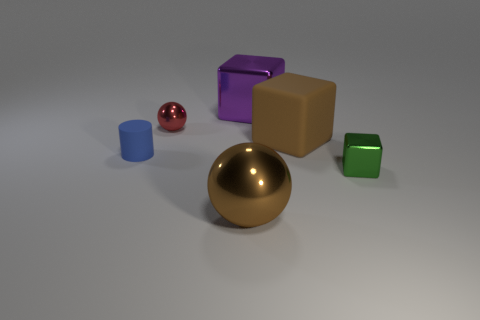Are there any other things that have the same size as the blue matte object?
Your answer should be compact. Yes. How many objects are large shiny objects behind the tiny blue thing or objects that are behind the tiny red thing?
Your answer should be very brief. 1. Do the metallic cube behind the blue rubber cylinder and the rubber thing right of the brown metal thing have the same size?
Make the answer very short. Yes. The tiny object that is the same shape as the big brown metallic object is what color?
Give a very brief answer. Red. Is there any other thing that has the same shape as the tiny blue object?
Offer a very short reply. No. Are there more small blue objects in front of the brown sphere than purple metallic objects that are in front of the blue matte cylinder?
Offer a very short reply. No. What is the size of the shiny block that is to the right of the brown thing on the right side of the ball that is in front of the blue thing?
Your response must be concise. Small. Is the material of the green thing the same as the thing that is left of the tiny red object?
Provide a succinct answer. No. Does the small blue rubber thing have the same shape as the purple thing?
Give a very brief answer. No. What number of other objects are the same material as the small green thing?
Your response must be concise. 3. 